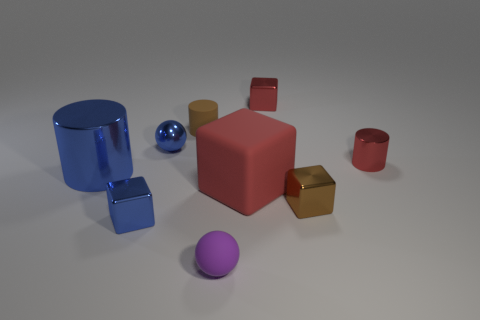How many small purple objects have the same shape as the large blue object?
Provide a short and direct response. 0. What is the shape of the big shiny object?
Your answer should be compact. Cylinder. Is the number of red cubes less than the number of red shiny blocks?
Your response must be concise. No. Are there any other things that have the same size as the purple sphere?
Keep it short and to the point. Yes. What is the material of the small brown thing that is the same shape as the big blue thing?
Your answer should be very brief. Rubber. Are there more gray metallic cubes than small cubes?
Ensure brevity in your answer.  No. What number of other objects are the same color as the rubber cylinder?
Your answer should be very brief. 1. Do the big cylinder and the ball that is right of the blue ball have the same material?
Ensure brevity in your answer.  No. How many blue shiny things are behind the small ball left of the tiny rubber object on the right side of the tiny brown matte cylinder?
Your answer should be very brief. 0. Are there fewer purple objects that are left of the brown matte object than large things to the right of the blue cylinder?
Ensure brevity in your answer.  Yes. 